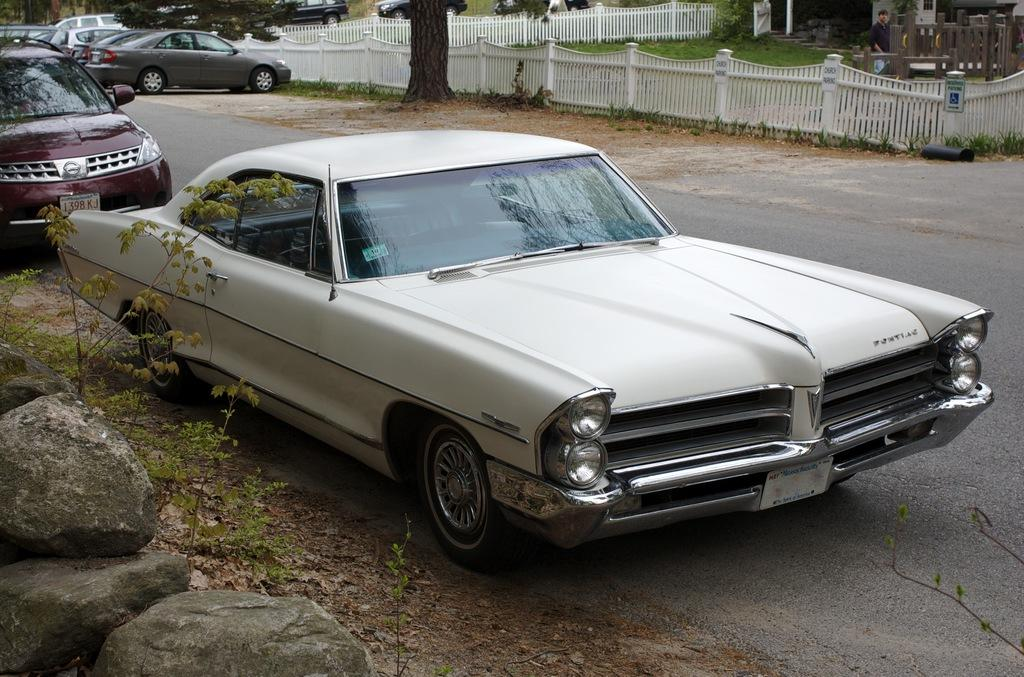What type of vehicles can be seen on the road in the image? There are cars on the road in the image. What else is visible near the cars? There are rocks beside the cars. What can be seen in the background of the image? There are trees and metal fencing in the background of the image. How does the distribution of rocks change during an earthquake in the image? There is no earthquake depicted in the image, and therefore no change in the distribution of rocks can be observed. 